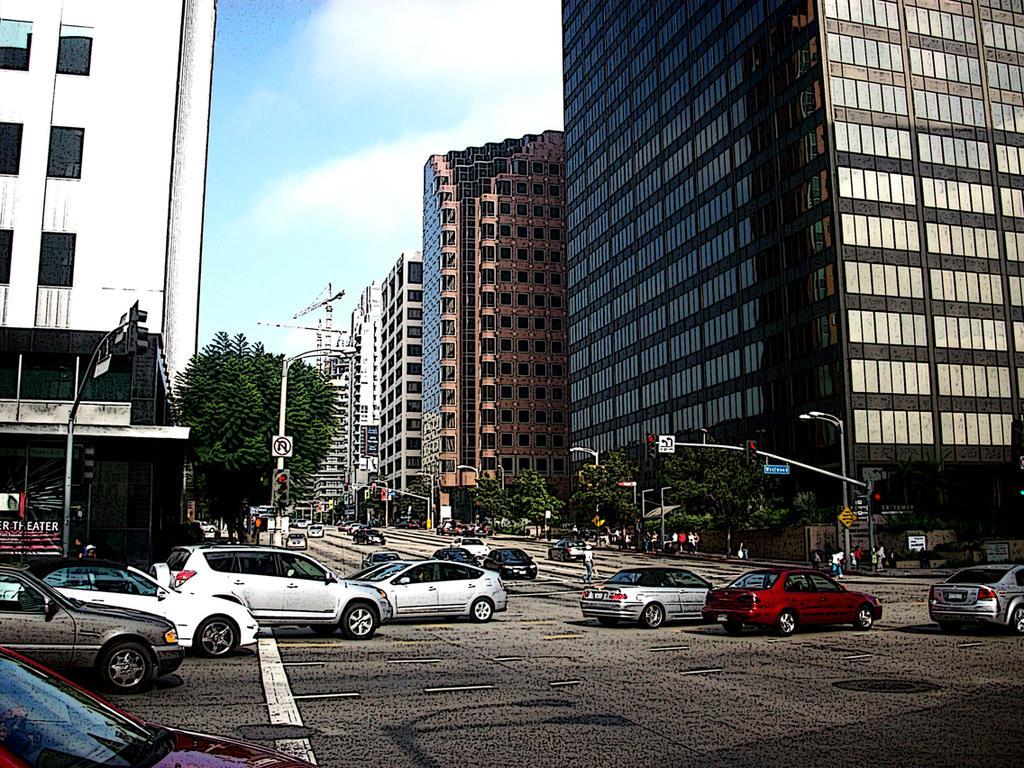How would you summarize this image in a sentence or two? In this image there are buildings and trees. We can see poles. There are boards. At the bottom there are cars on the road. We can see people. In the background there is sky. 